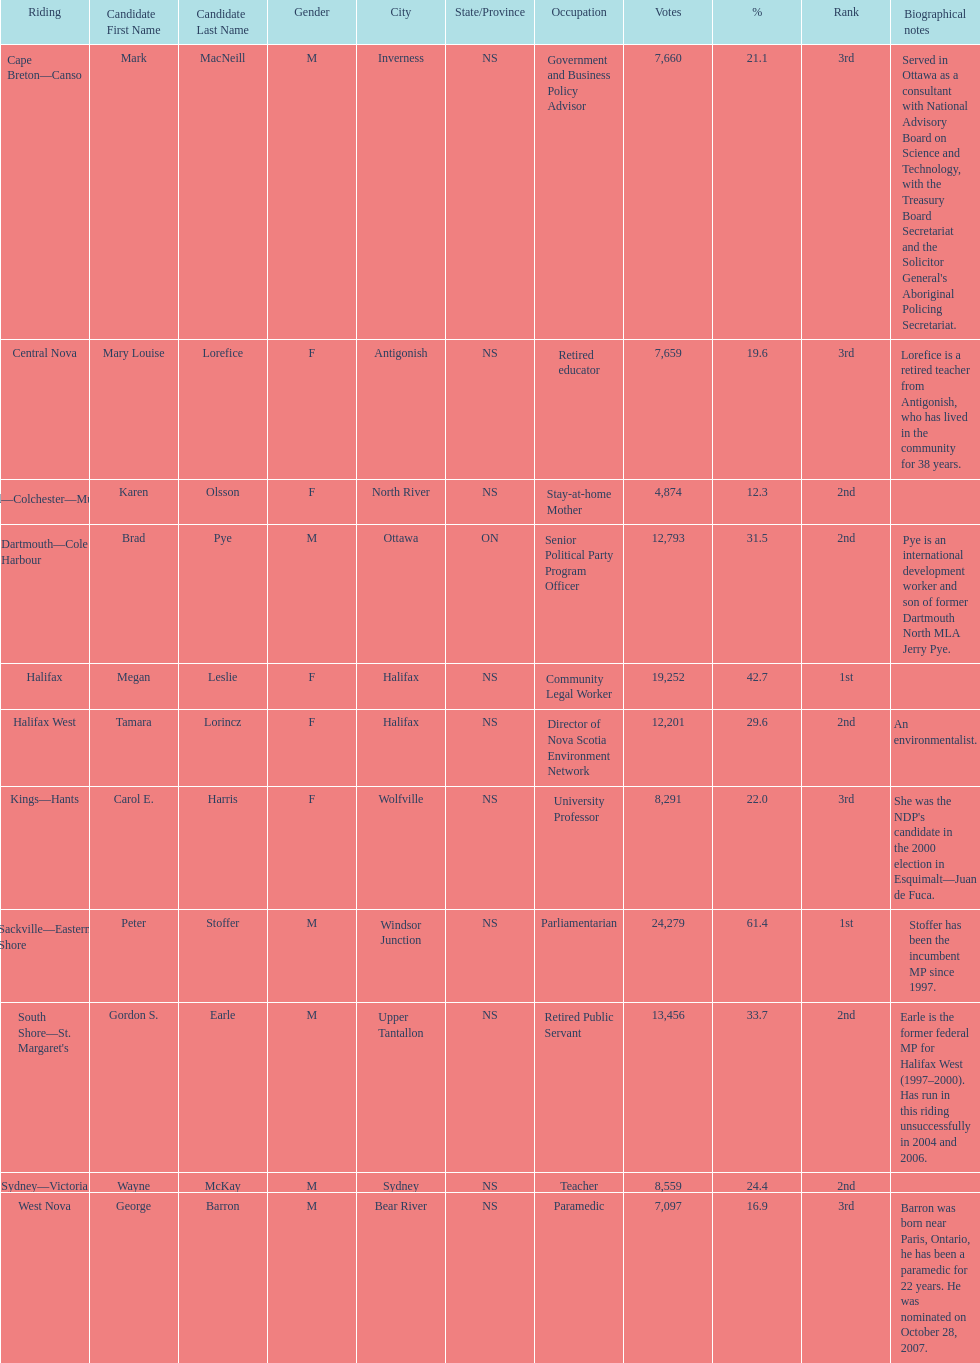Parse the table in full. {'header': ['Riding', 'Candidate First Name', 'Candidate Last Name', 'Gender', 'City', 'State/Province', 'Occupation', 'Votes', '%', 'Rank', 'Biographical notes'], 'rows': [['Cape Breton—Canso', 'Mark', 'MacNeill', 'M', 'Inverness', 'NS', 'Government and Business Policy Advisor', '7,660', '21.1', '3rd', "Served in Ottawa as a consultant with National Advisory Board on Science and Technology, with the Treasury Board Secretariat and the Solicitor General's Aboriginal Policing Secretariat."], ['Central Nova', 'Mary Louise', 'Lorefice', 'F', 'Antigonish', 'NS', 'Retired educator', '7,659', '19.6', '3rd', 'Lorefice is a retired teacher from Antigonish, who has lived in the community for 38 years.'], ['Cumberland—Colchester—Musquodoboit Valley', 'Karen', 'Olsson', 'F', 'North River', 'NS', 'Stay-at-home Mother', '4,874', '12.3', '2nd', ''], ['Dartmouth—Cole Harbour', 'Brad', 'Pye', 'M', 'Ottawa', 'ON', 'Senior Political Party Program Officer', '12,793', '31.5', '2nd', 'Pye is an international development worker and son of former Dartmouth North MLA Jerry Pye.'], ['Halifax', 'Megan', 'Leslie', 'F', 'Halifax', 'NS', 'Community Legal Worker', '19,252', '42.7', '1st', ''], ['Halifax West', 'Tamara', 'Lorincz', 'F', 'Halifax', 'NS', 'Director of Nova Scotia Environment Network', '12,201', '29.6', '2nd', 'An environmentalist.'], ['Kings—Hants', 'Carol E.', 'Harris', 'F', 'Wolfville', 'NS', 'University Professor', '8,291', '22.0', '3rd', "She was the NDP's candidate in the 2000 election in Esquimalt—Juan de Fuca."], ['Sackville—Eastern Shore', 'Peter', 'Stoffer', 'M', 'Windsor Junction', 'NS', 'Parliamentarian', '24,279', '61.4', '1st', 'Stoffer has been the incumbent MP since 1997.'], ["South Shore—St. Margaret's", 'Gordon S.', 'Earle', 'M', 'Upper Tantallon', 'NS', 'Retired Public Servant', '13,456', '33.7', '2nd', 'Earle is the former federal MP for Halifax West (1997–2000). Has run in this riding unsuccessfully in 2004 and 2006.'], ['Sydney—Victoria', 'Wayne', 'McKay', 'M', 'Sydney', 'NS', 'Teacher', '8,559', '24.4', '2nd', ''], ['West Nova', 'George', 'Barron', 'M', 'Bear River', 'NS', 'Paramedic', '7,097', '16.9', '3rd', 'Barron was born near Paris, Ontario, he has been a paramedic for 22 years. He was nominated on October 28, 2007.']]} Who has the most votes? Sackville-Eastern Shore. 